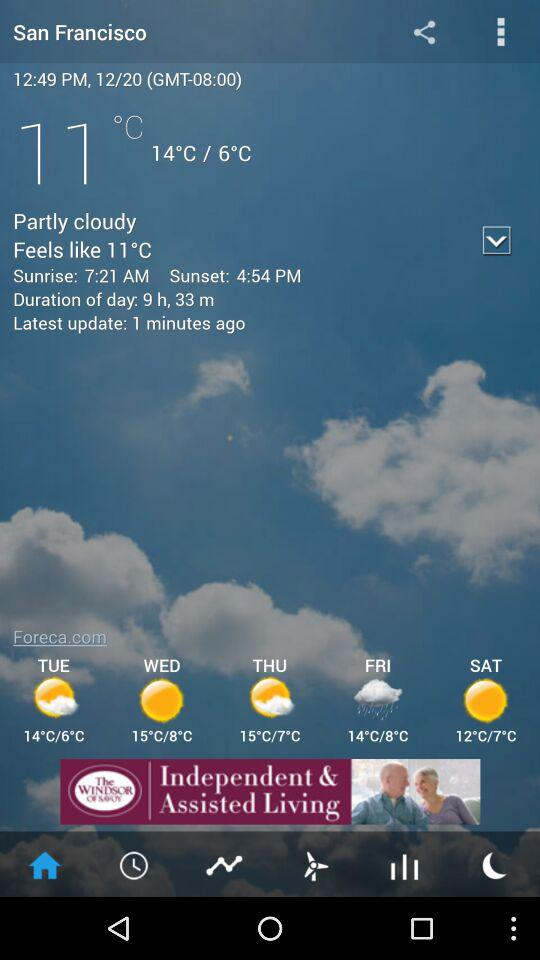How is the weather in San Francisco? The weather is partly cloudy. 